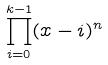Convert formula to latex. <formula><loc_0><loc_0><loc_500><loc_500>\prod _ { i = 0 } ^ { k - 1 } ( x - i ) ^ { n }</formula> 